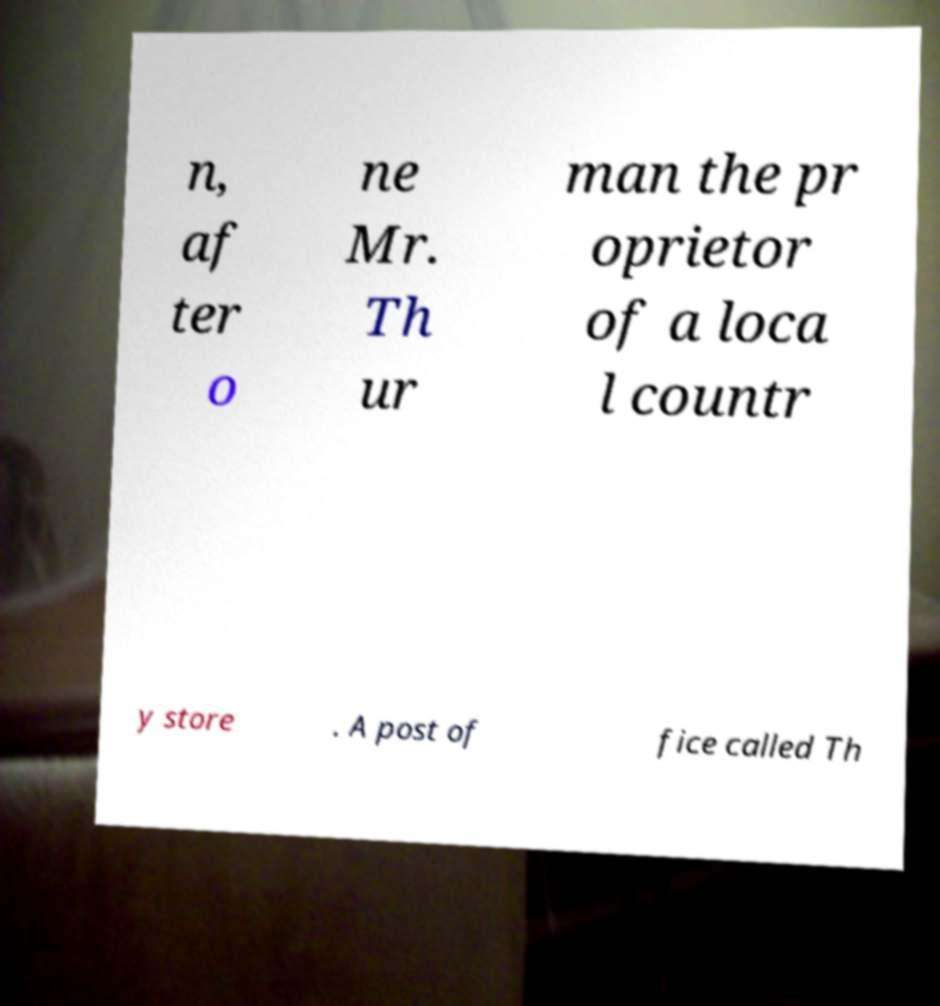What messages or text are displayed in this image? I need them in a readable, typed format. n, af ter o ne Mr. Th ur man the pr oprietor of a loca l countr y store . A post of fice called Th 